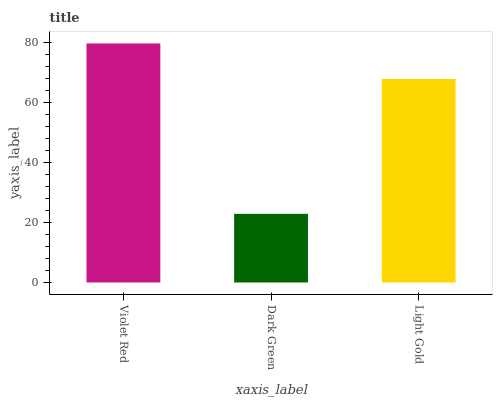Is Dark Green the minimum?
Answer yes or no. Yes. Is Violet Red the maximum?
Answer yes or no. Yes. Is Light Gold the minimum?
Answer yes or no. No. Is Light Gold the maximum?
Answer yes or no. No. Is Light Gold greater than Dark Green?
Answer yes or no. Yes. Is Dark Green less than Light Gold?
Answer yes or no. Yes. Is Dark Green greater than Light Gold?
Answer yes or no. No. Is Light Gold less than Dark Green?
Answer yes or no. No. Is Light Gold the high median?
Answer yes or no. Yes. Is Light Gold the low median?
Answer yes or no. Yes. Is Violet Red the high median?
Answer yes or no. No. Is Dark Green the low median?
Answer yes or no. No. 